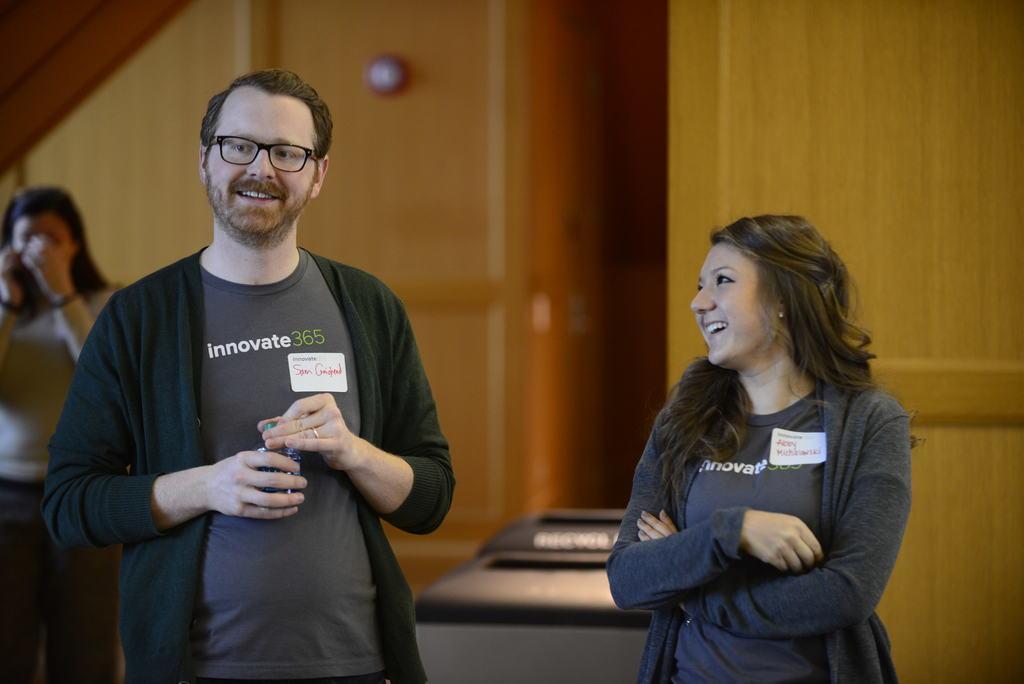Could you give a brief overview of what you see in this image? This is the man and woman standing and smiling. This looks like an object. I think this is the wooden wall. In the background, I can see another woman standing. 